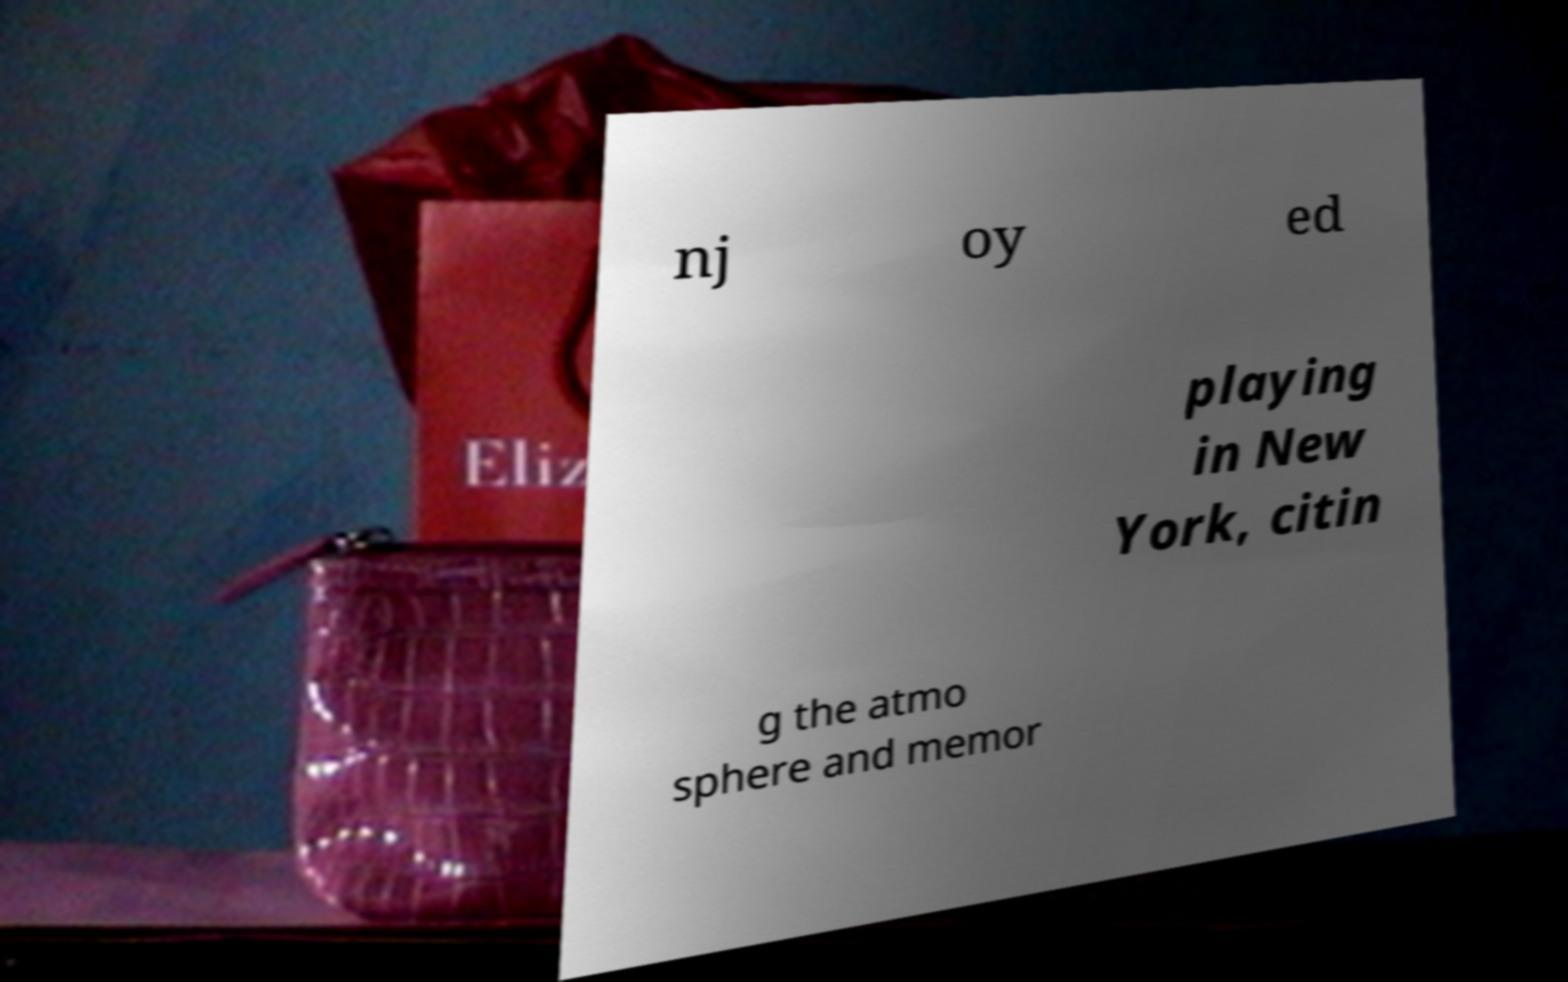For documentation purposes, I need the text within this image transcribed. Could you provide that? nj oy ed playing in New York, citin g the atmo sphere and memor 